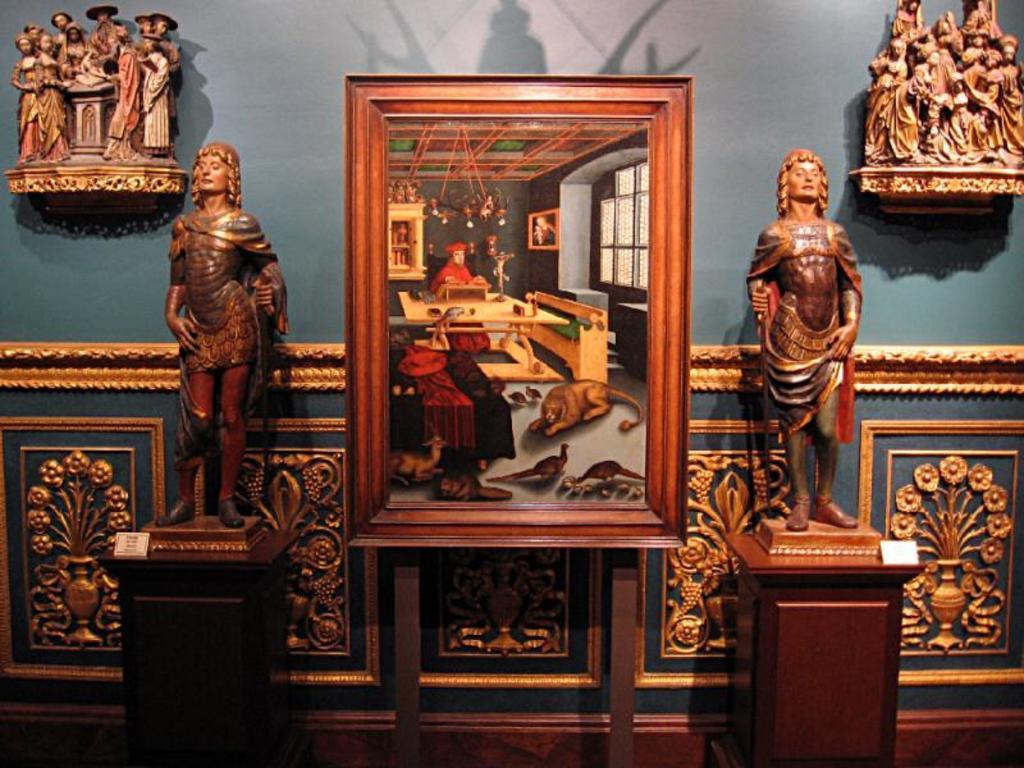Could you give a brief overview of what you see in this image? In this image, we can see statues and there is a frame. In the background, there are sculptures on the wall. 